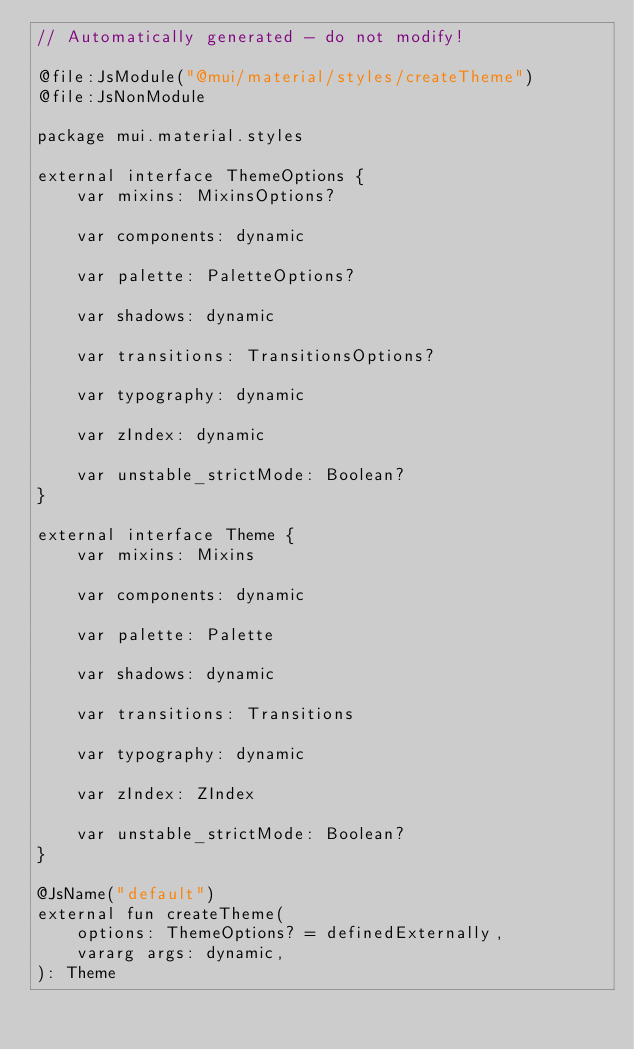<code> <loc_0><loc_0><loc_500><loc_500><_Kotlin_>// Automatically generated - do not modify!

@file:JsModule("@mui/material/styles/createTheme")
@file:JsNonModule

package mui.material.styles

external interface ThemeOptions {
    var mixins: MixinsOptions?

    var components: dynamic

    var palette: PaletteOptions?

    var shadows: dynamic

    var transitions: TransitionsOptions?

    var typography: dynamic

    var zIndex: dynamic

    var unstable_strictMode: Boolean?
}

external interface Theme {
    var mixins: Mixins

    var components: dynamic

    var palette: Palette

    var shadows: dynamic

    var transitions: Transitions

    var typography: dynamic

    var zIndex: ZIndex

    var unstable_strictMode: Boolean?
}

@JsName("default")
external fun createTheme(
    options: ThemeOptions? = definedExternally,
    vararg args: dynamic,
): Theme
</code> 